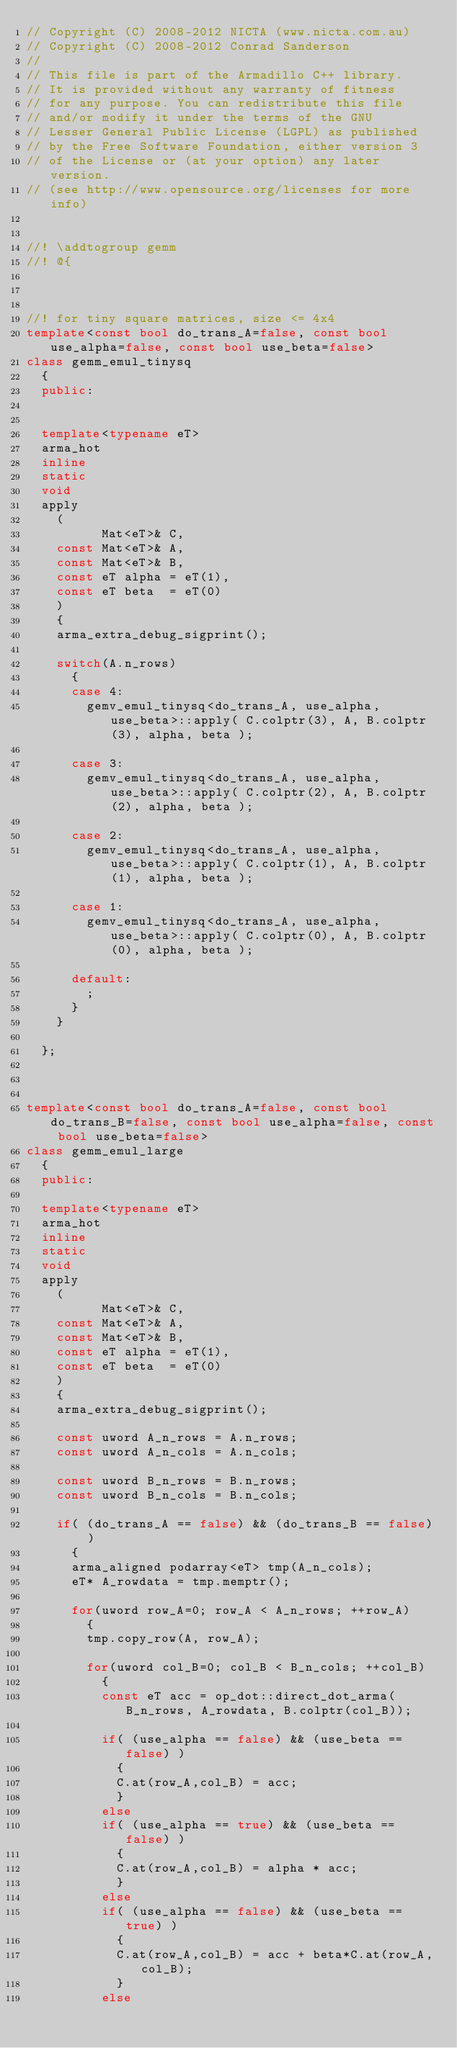Convert code to text. <code><loc_0><loc_0><loc_500><loc_500><_C++_>// Copyright (C) 2008-2012 NICTA (www.nicta.com.au)
// Copyright (C) 2008-2012 Conrad Sanderson
// 
// This file is part of the Armadillo C++ library.
// It is provided without any warranty of fitness
// for any purpose. You can redistribute this file
// and/or modify it under the terms of the GNU
// Lesser General Public License (LGPL) as published
// by the Free Software Foundation, either version 3
// of the License or (at your option) any later version.
// (see http://www.opensource.org/licenses for more info)


//! \addtogroup gemm
//! @{



//! for tiny square matrices, size <= 4x4
template<const bool do_trans_A=false, const bool use_alpha=false, const bool use_beta=false>
class gemm_emul_tinysq
  {
  public:
  
  
  template<typename eT>
  arma_hot
  inline
  static
  void
  apply
    (
          Mat<eT>& C,
    const Mat<eT>& A,
    const Mat<eT>& B,
    const eT alpha = eT(1),
    const eT beta  = eT(0)
    )
    {
    arma_extra_debug_sigprint();
    
    switch(A.n_rows)
      {
      case 4:
        gemv_emul_tinysq<do_trans_A, use_alpha, use_beta>::apply( C.colptr(3), A, B.colptr(3), alpha, beta );
        
      case 3:
        gemv_emul_tinysq<do_trans_A, use_alpha, use_beta>::apply( C.colptr(2), A, B.colptr(2), alpha, beta );
        
      case 2:
        gemv_emul_tinysq<do_trans_A, use_alpha, use_beta>::apply( C.colptr(1), A, B.colptr(1), alpha, beta );
        
      case 1:
        gemv_emul_tinysq<do_trans_A, use_alpha, use_beta>::apply( C.colptr(0), A, B.colptr(0), alpha, beta );
        
      default:
        ;
      }
    }
  
  };



template<const bool do_trans_A=false, const bool do_trans_B=false, const bool use_alpha=false, const bool use_beta=false>
class gemm_emul_large
  {
  public:
  
  template<typename eT>
  arma_hot
  inline
  static
  void
  apply
    (
          Mat<eT>& C,
    const Mat<eT>& A,
    const Mat<eT>& B,
    const eT alpha = eT(1),
    const eT beta  = eT(0)
    )
    {
    arma_extra_debug_sigprint();

    const uword A_n_rows = A.n_rows;
    const uword A_n_cols = A.n_cols;
    
    const uword B_n_rows = B.n_rows;
    const uword B_n_cols = B.n_cols;
    
    if( (do_trans_A == false) && (do_trans_B == false) )
      {
      arma_aligned podarray<eT> tmp(A_n_cols);
      eT* A_rowdata = tmp.memptr();
      
      for(uword row_A=0; row_A < A_n_rows; ++row_A)
        {
        tmp.copy_row(A, row_A);
        
        for(uword col_B=0; col_B < B_n_cols; ++col_B)
          {
          const eT acc = op_dot::direct_dot_arma(B_n_rows, A_rowdata, B.colptr(col_B));
          
          if( (use_alpha == false) && (use_beta == false) )
            {
            C.at(row_A,col_B) = acc;
            }
          else
          if( (use_alpha == true) && (use_beta == false) )
            {
            C.at(row_A,col_B) = alpha * acc;
            }
          else
          if( (use_alpha == false) && (use_beta == true) )
            {
            C.at(row_A,col_B) = acc + beta*C.at(row_A,col_B);
            }
          else</code> 